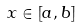<formula> <loc_0><loc_0><loc_500><loc_500>x \in [ a , b ]</formula> 